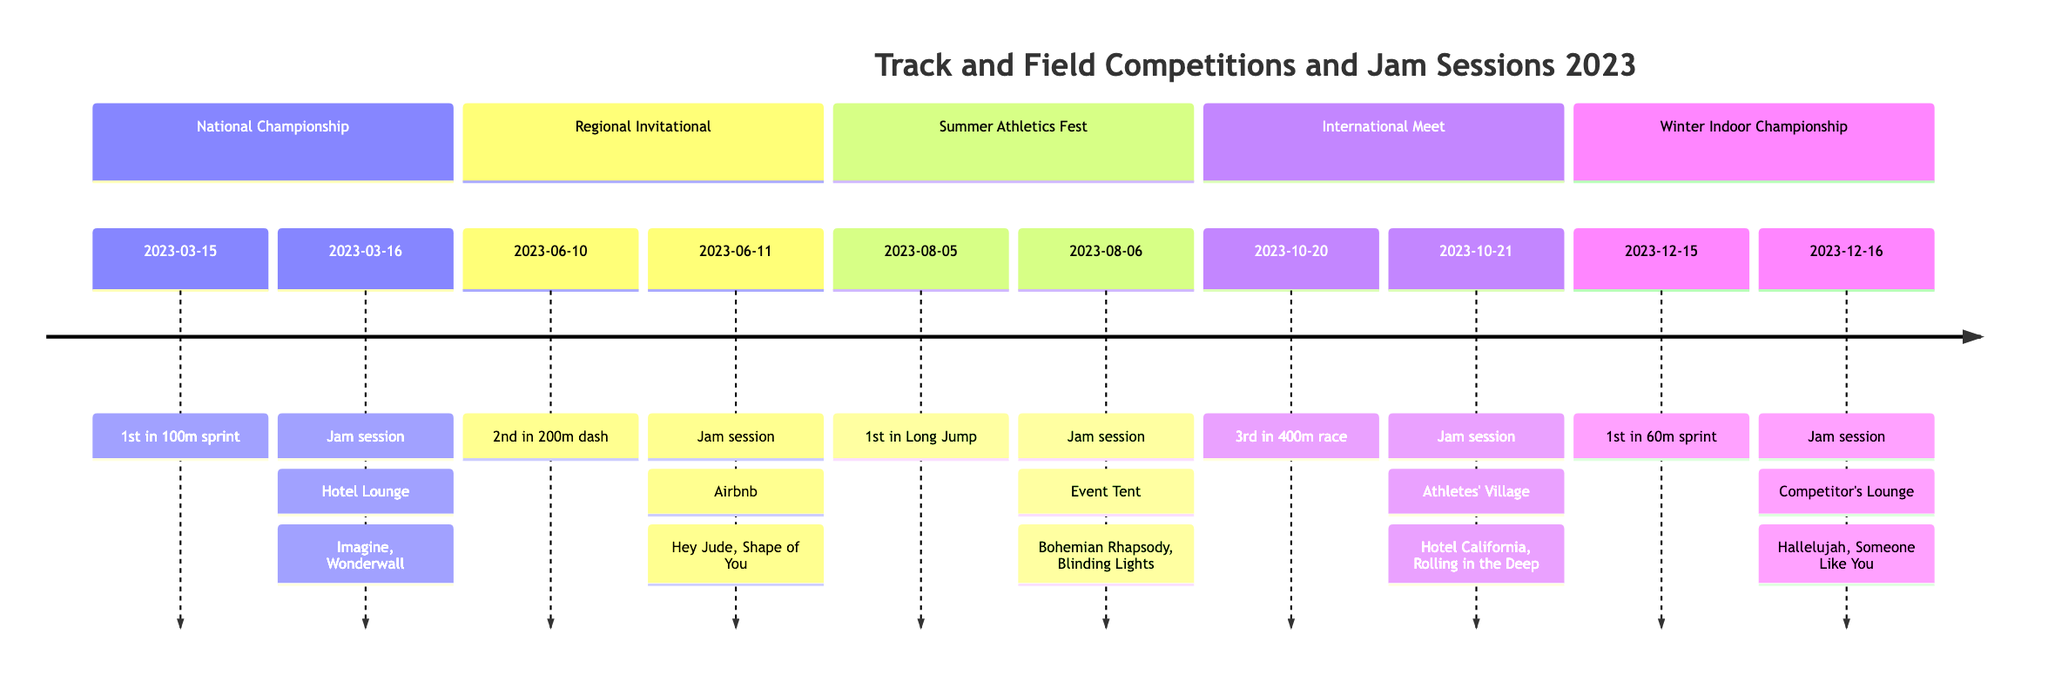What was the location of the National Track and Field Championship? The timeline entry for the National Track and Field Championship indicates that the location was Los Angeles, CA.
Answer: Los Angeles, CA What was the result of the Summer Athletics Fest? Referring to the timeline, the result for the Summer Athletics Fest was 1st place in Long Jump.
Answer: 1st place in Long Jump Who were the participants in the jam session after the International Track Meet? The jam session following the International Track Meet had Jamie and Skyler as participants, as stated in the timeline.
Answer: Jamie, Skyler How many total events are represented in the timeline? By counting the number of unique entries in the timeline, we find that there are five events listed.
Answer: 5 What memorable moment is associated with the Regional Invitational Meet? The timeline mentions that the memorable moment for the Regional Invitational Meet was a close finish with a rival.
Answer: Close finish with rival Which song was performed during the jam session after the Summer Athletics Fest? The jam session after the Summer Athletics Fest included the song "Bohemian Rhapsody" by Queen, as noted in the timeline.
Answer: Bohemian Rhapsody Which event took place in October? The timeline indicates the International Track Meet occurred on October 20, 2023.
Answer: International Track Meet What was the date of the jam session following the National Track and Field Championship? By examining the timeline, the jam session following the National Track and Field Championship took place on March 16, 2023.
Answer: March 16, 2023 What song did participants perform in the last jam session of the year? According to the timeline, one of the songs performed in the last jam session was "Hallelujah" by Leonard Cohen.
Answer: Hallelujah 